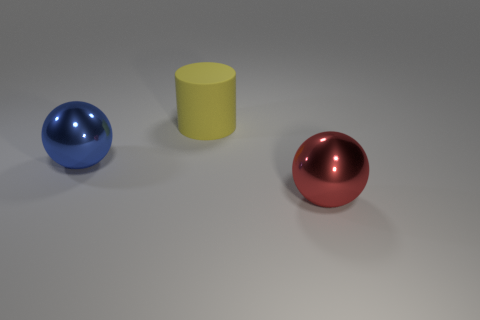Is the number of yellow matte things to the left of the blue shiny object the same as the number of blue objects to the right of the large rubber cylinder?
Keep it short and to the point. Yes. Are there any red objects?
Offer a very short reply. Yes. What is the size of the red metallic object that is the same shape as the blue thing?
Offer a terse response. Large. There is a thing on the left side of the big yellow matte cylinder; what is its size?
Keep it short and to the point. Large. Are there more large red shiny objects to the right of the big red metallic sphere than large purple spheres?
Offer a very short reply. No. The big rubber object is what shape?
Provide a short and direct response. Cylinder. Does the metallic object that is to the right of the cylinder have the same color as the big sphere that is behind the red shiny object?
Give a very brief answer. No. Is the big yellow object the same shape as the blue thing?
Provide a short and direct response. No. Are there any other things that are the same shape as the blue metallic object?
Provide a succinct answer. Yes. Do the object on the left side of the matte object and the red thing have the same material?
Offer a very short reply. Yes. 